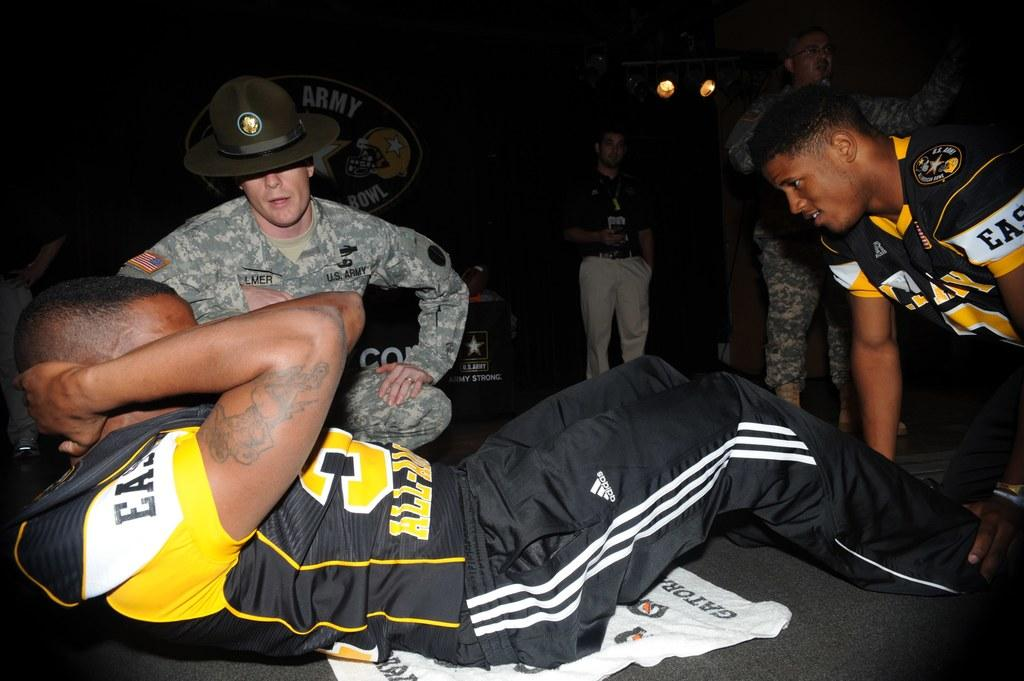<image>
Relay a brief, clear account of the picture shown. A member of the East All American team is doing sit ups and another player is holding his feet down. 